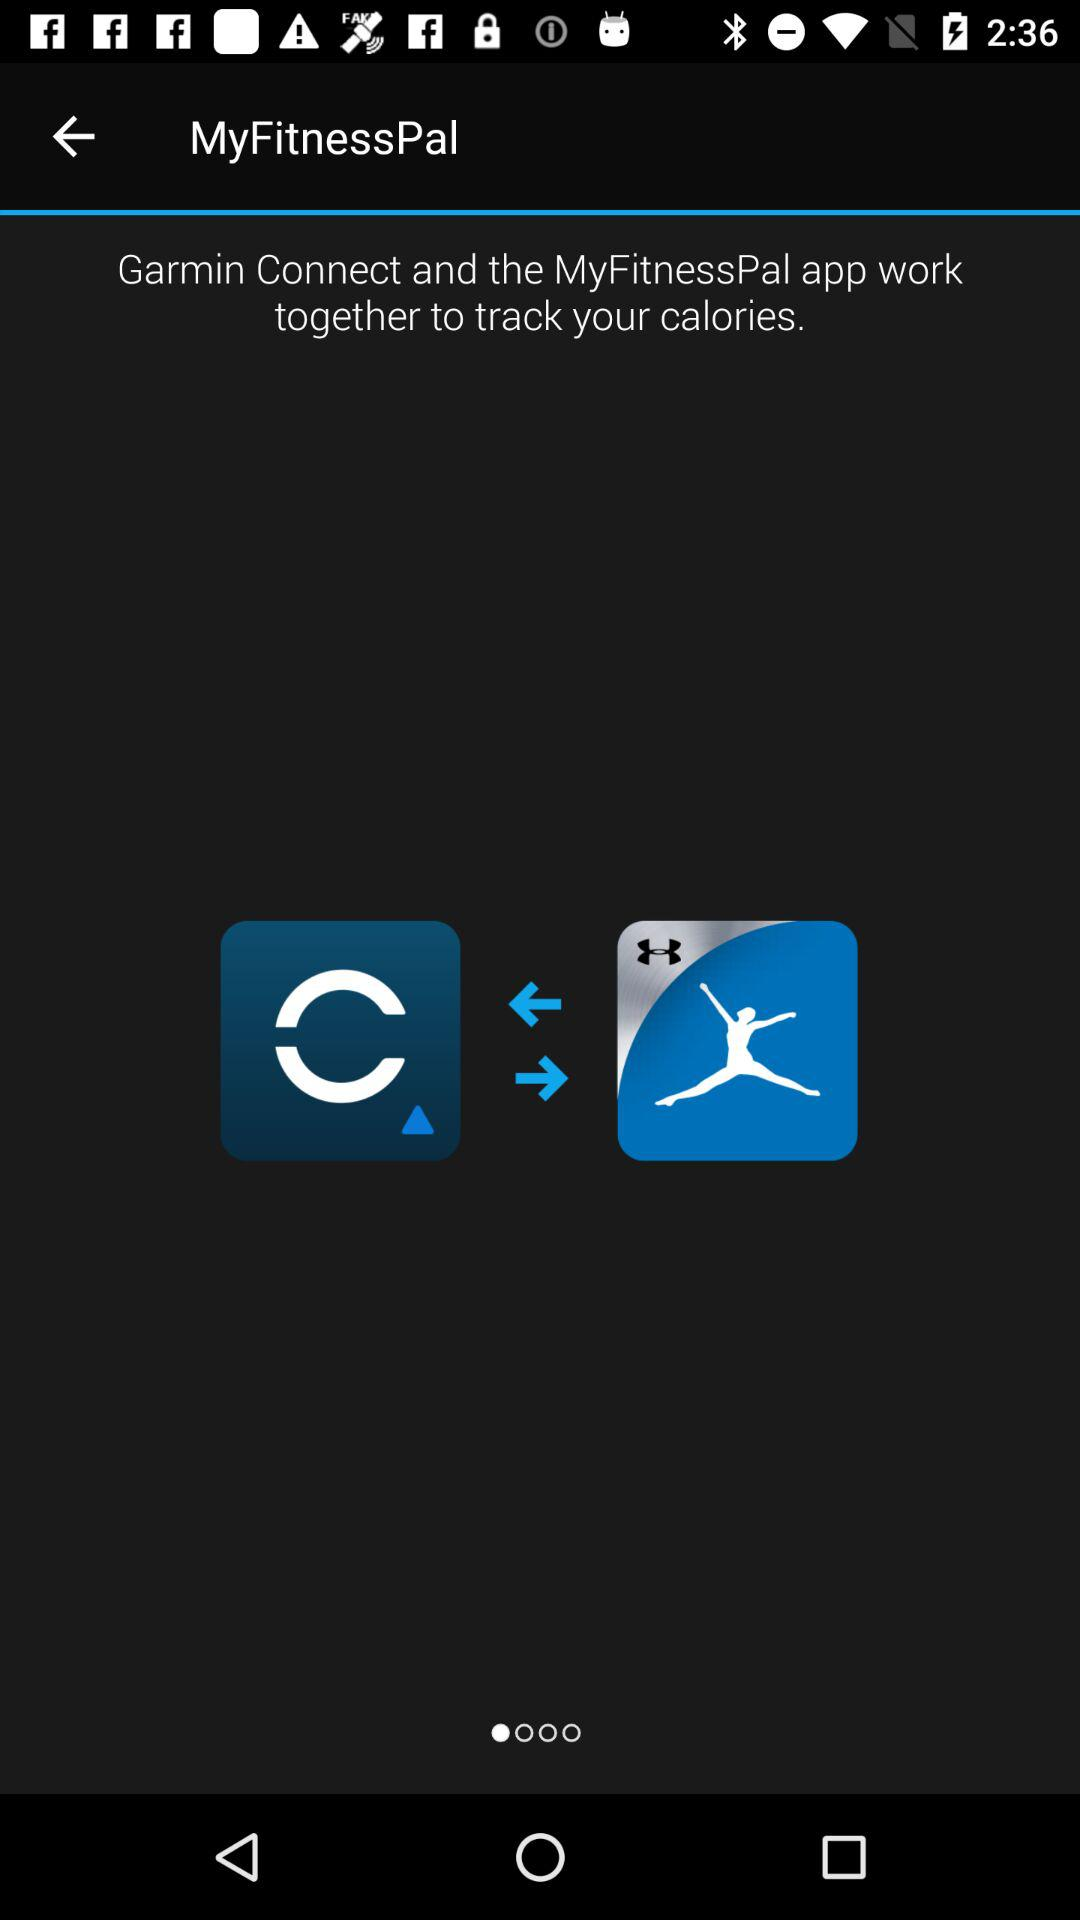How many more arrows are there than basketball players?
Answer the question using a single word or phrase. 2 